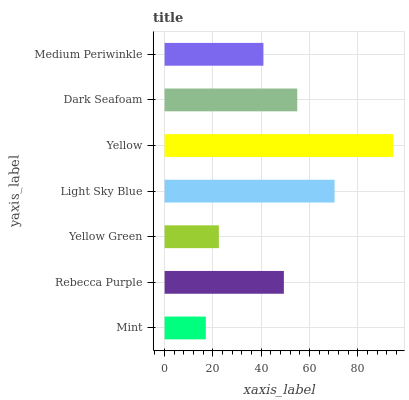Is Mint the minimum?
Answer yes or no. Yes. Is Yellow the maximum?
Answer yes or no. Yes. Is Rebecca Purple the minimum?
Answer yes or no. No. Is Rebecca Purple the maximum?
Answer yes or no. No. Is Rebecca Purple greater than Mint?
Answer yes or no. Yes. Is Mint less than Rebecca Purple?
Answer yes or no. Yes. Is Mint greater than Rebecca Purple?
Answer yes or no. No. Is Rebecca Purple less than Mint?
Answer yes or no. No. Is Rebecca Purple the high median?
Answer yes or no. Yes. Is Rebecca Purple the low median?
Answer yes or no. Yes. Is Mint the high median?
Answer yes or no. No. Is Yellow the low median?
Answer yes or no. No. 